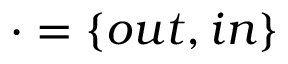Convert formula to latex. <formula><loc_0><loc_0><loc_500><loc_500>\cdot = \{ o u t , i n \}</formula> 